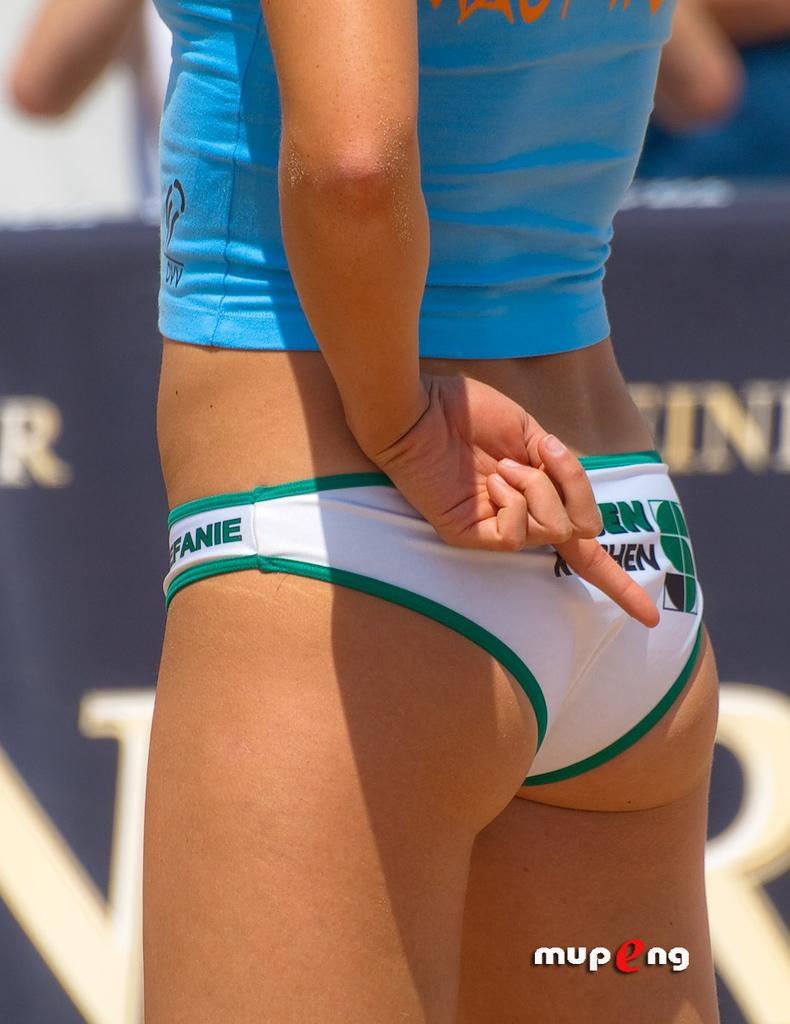<image>
Render a clear and concise summary of the photo. A mupeng picture of the behind of an athlete who has one finger extened 